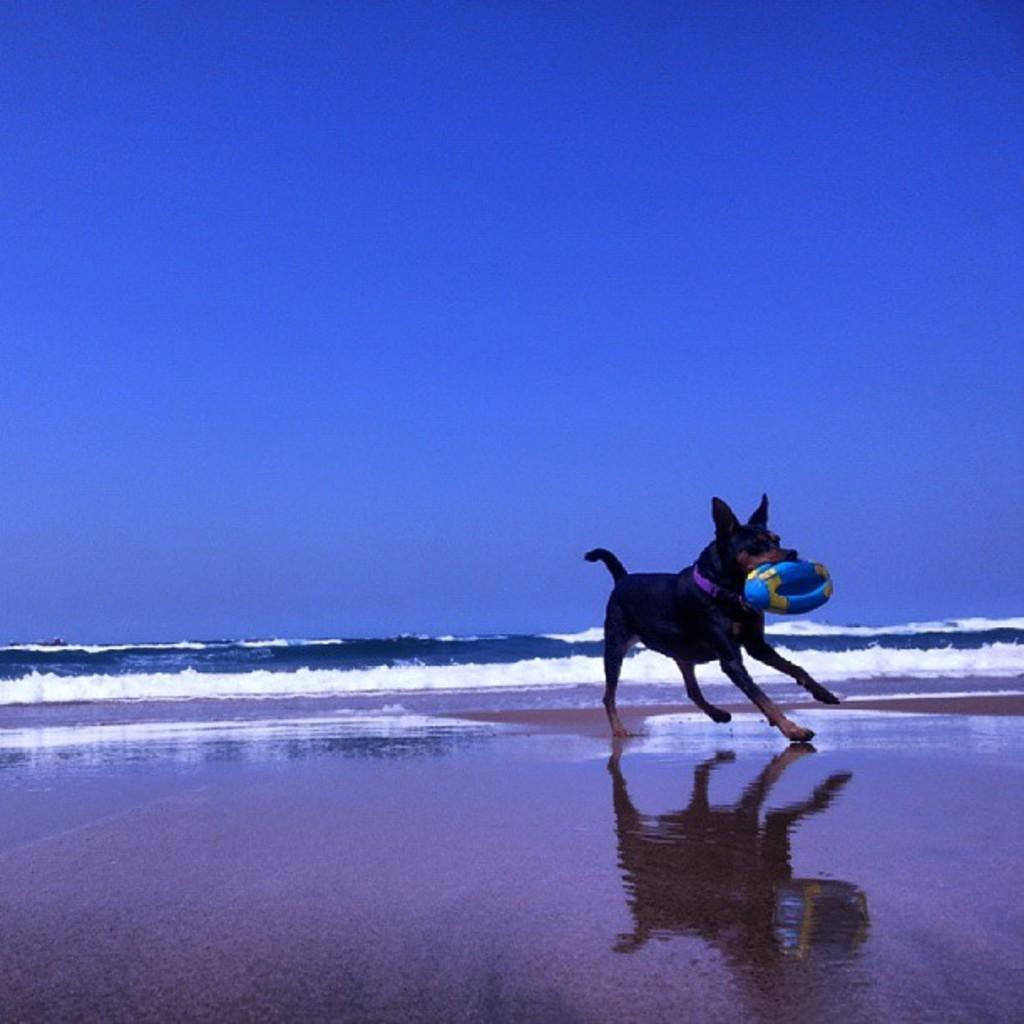Please provide a concise description of this image. In the center of the image we can see ball and dog at the sea shore. In the background we can see water and sky. 